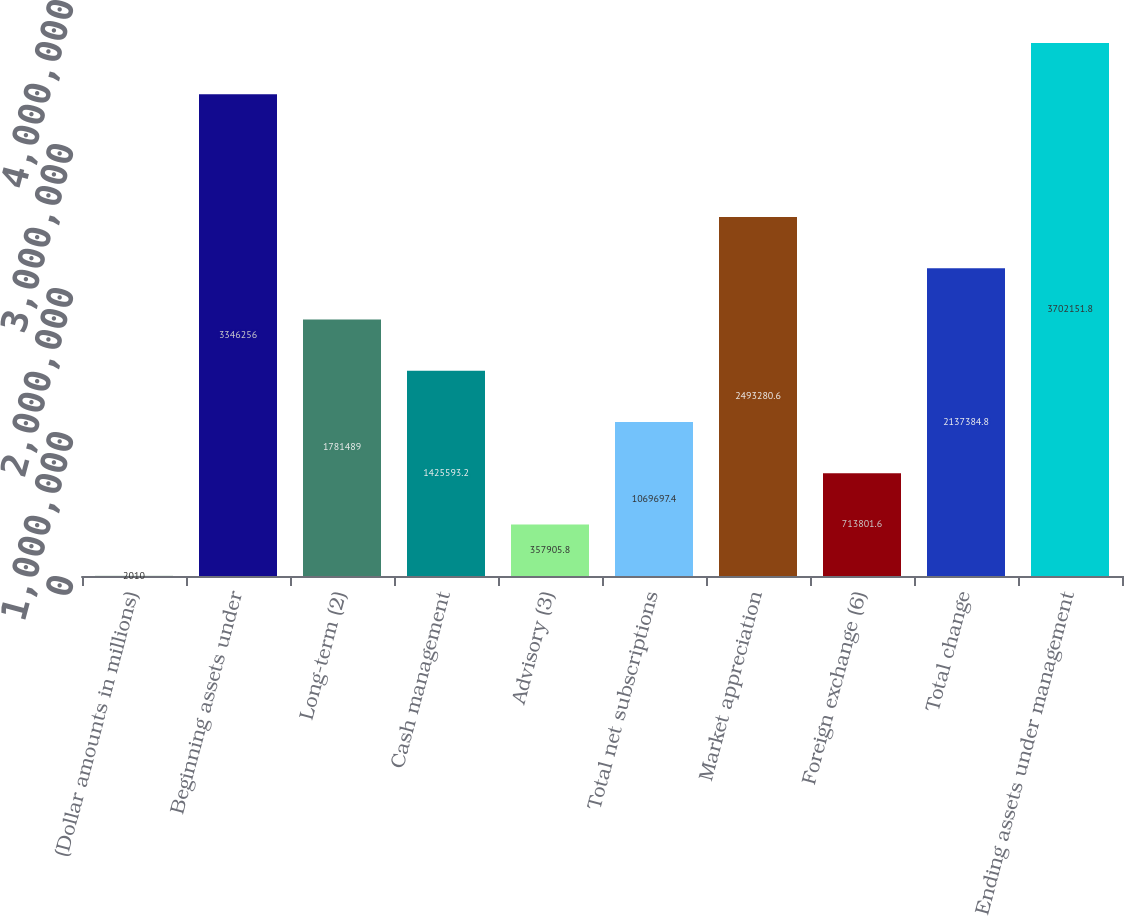<chart> <loc_0><loc_0><loc_500><loc_500><bar_chart><fcel>(Dollar amounts in millions)<fcel>Beginning assets under<fcel>Long-term (2)<fcel>Cash management<fcel>Advisory (3)<fcel>Total net subscriptions<fcel>Market appreciation<fcel>Foreign exchange (6)<fcel>Total change<fcel>Ending assets under management<nl><fcel>2010<fcel>3.34626e+06<fcel>1.78149e+06<fcel>1.42559e+06<fcel>357906<fcel>1.0697e+06<fcel>2.49328e+06<fcel>713802<fcel>2.13738e+06<fcel>3.70215e+06<nl></chart> 